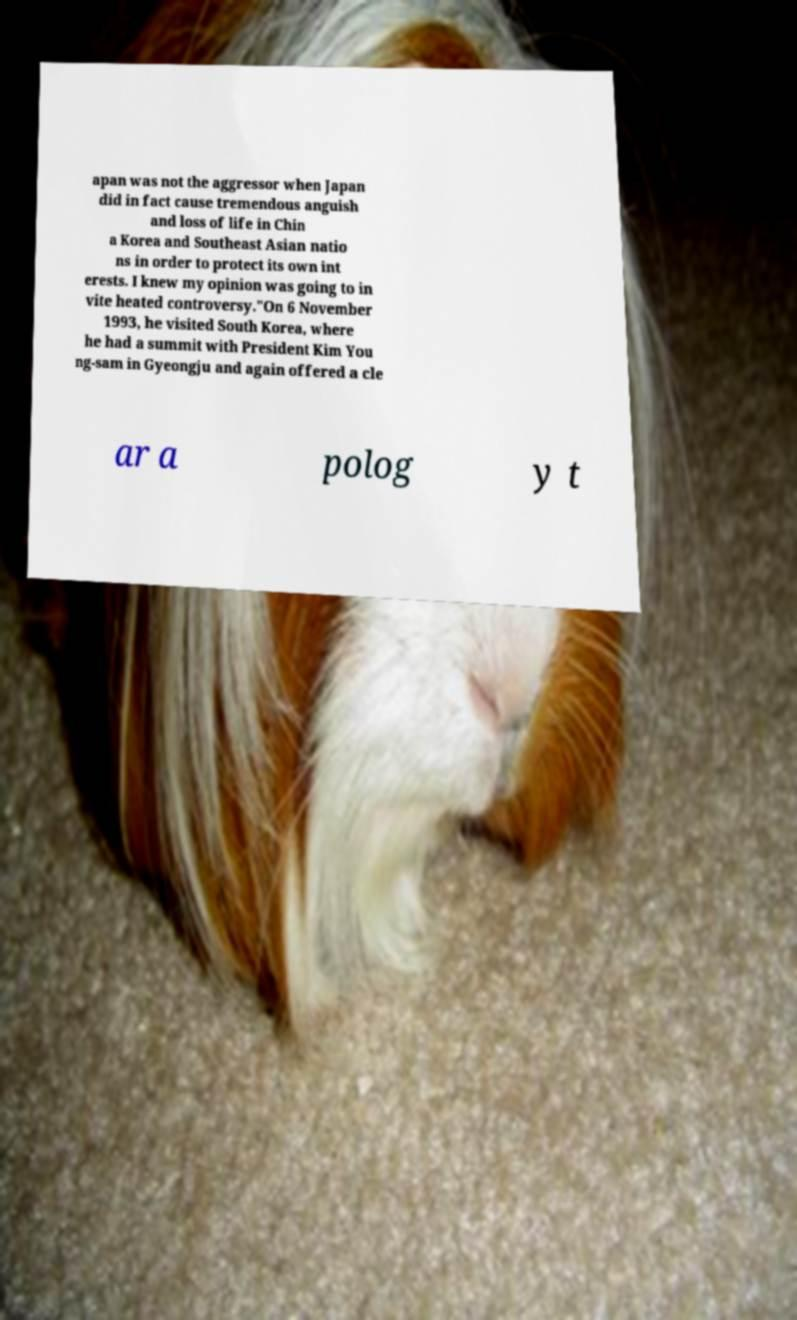Could you extract and type out the text from this image? apan was not the aggressor when Japan did in fact cause tremendous anguish and loss of life in Chin a Korea and Southeast Asian natio ns in order to protect its own int erests. I knew my opinion was going to in vite heated controversy."On 6 November 1993, he visited South Korea, where he had a summit with President Kim You ng-sam in Gyeongju and again offered a cle ar a polog y t 